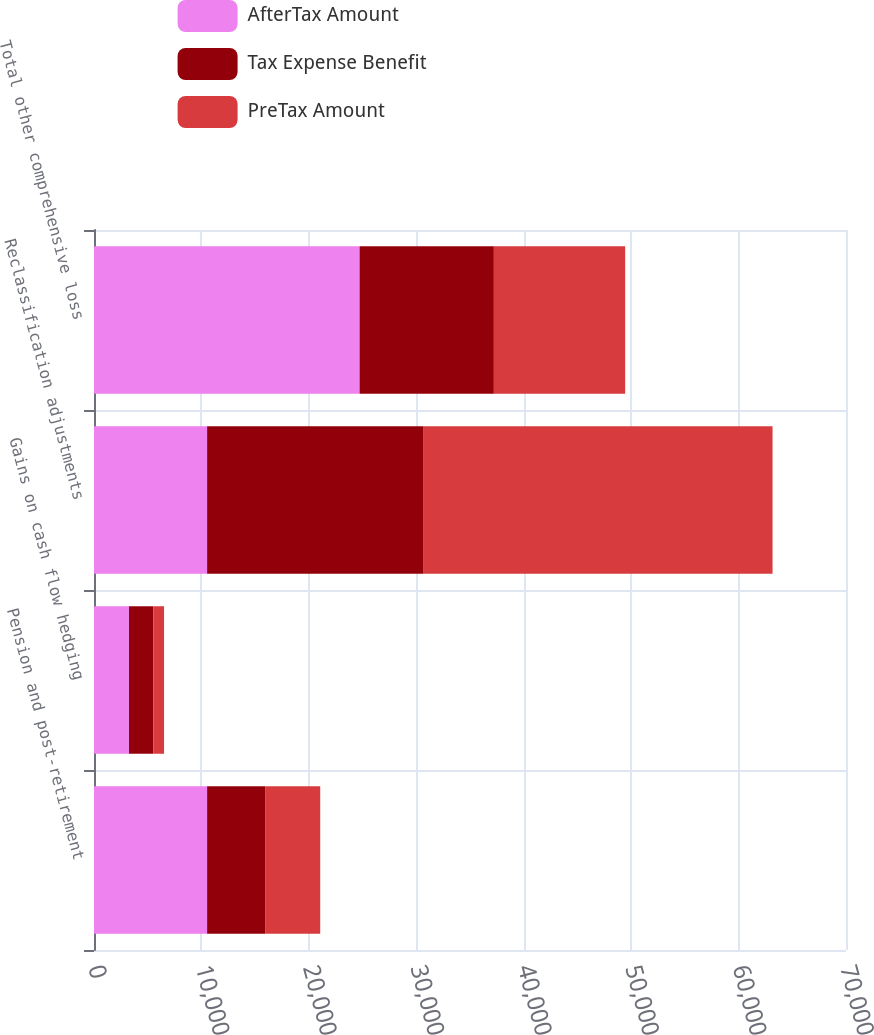<chart> <loc_0><loc_0><loc_500><loc_500><stacked_bar_chart><ecel><fcel>Pension and post-retirement<fcel>Gains on cash flow hedging<fcel>Reclassification adjustments<fcel>Total other comprehensive loss<nl><fcel>AfterTax Amount<fcel>10529<fcel>3260<fcel>10529<fcel>24722<nl><fcel>Tax Expense Benefit<fcel>5399<fcel>2259<fcel>20157<fcel>12499<nl><fcel>PreTax Amount<fcel>5130<fcel>1001<fcel>32477<fcel>12223<nl></chart> 